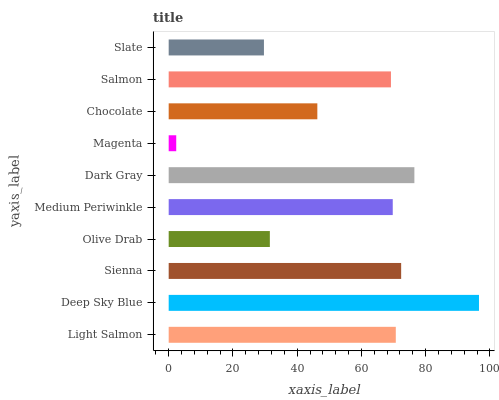Is Magenta the minimum?
Answer yes or no. Yes. Is Deep Sky Blue the maximum?
Answer yes or no. Yes. Is Sienna the minimum?
Answer yes or no. No. Is Sienna the maximum?
Answer yes or no. No. Is Deep Sky Blue greater than Sienna?
Answer yes or no. Yes. Is Sienna less than Deep Sky Blue?
Answer yes or no. Yes. Is Sienna greater than Deep Sky Blue?
Answer yes or no. No. Is Deep Sky Blue less than Sienna?
Answer yes or no. No. Is Medium Periwinkle the high median?
Answer yes or no. Yes. Is Salmon the low median?
Answer yes or no. Yes. Is Chocolate the high median?
Answer yes or no. No. Is Sienna the low median?
Answer yes or no. No. 